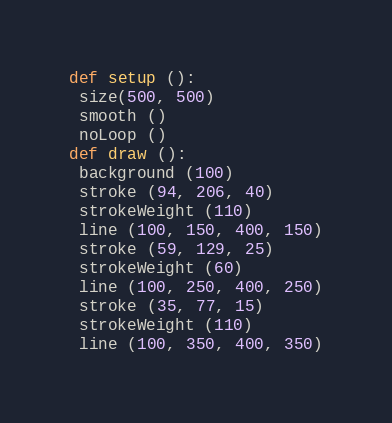Convert code to text. <code><loc_0><loc_0><loc_500><loc_500><_Python_>def setup ():
 size(500, 500)
 smooth ()
 noLoop ()
def draw ():
 background (100)
 stroke (94, 206, 40)
 strokeWeight (110)
 line (100, 150, 400, 150)
 stroke (59, 129, 25)
 strokeWeight (60)
 line (100, 250, 400, 250)
 stroke (35, 77, 15)
 strokeWeight (110)
 line (100, 350, 400, 350)
</code> 